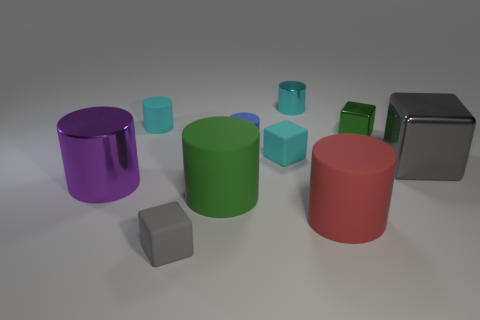How many green rubber balls are the same size as the red cylinder?
Your answer should be compact. 0. What is the green block made of?
Offer a terse response. Metal. Does the small metal cylinder have the same color as the small matte cube right of the small gray thing?
Give a very brief answer. Yes. There is a block that is both left of the red thing and behind the green cylinder; what is its size?
Make the answer very short. Small. What is the shape of the big gray thing that is made of the same material as the tiny green object?
Your answer should be compact. Cube. Does the blue cylinder have the same material as the tiny cyan cylinder right of the blue rubber thing?
Ensure brevity in your answer.  No. There is a tiny matte cylinder that is behind the tiny blue cylinder; are there any large purple metallic cylinders on the left side of it?
Your response must be concise. Yes. What is the material of the purple object that is the same shape as the green rubber object?
Ensure brevity in your answer.  Metal. How many blue cylinders are on the left side of the tiny matte block that is in front of the big red cylinder?
Provide a short and direct response. 0. Are there any other things of the same color as the big cube?
Keep it short and to the point. Yes. 